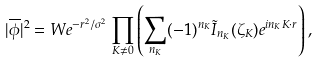Convert formula to latex. <formula><loc_0><loc_0><loc_500><loc_500>| \overline { \phi } | ^ { 2 } = W e ^ { - r ^ { 2 } / \sigma ^ { 2 } } \prod _ { { K } \neq 0 } \left ( \sum _ { n _ { K } } ( - 1 ) ^ { n _ { K } } \tilde { I } _ { n _ { K } } ( \zeta _ { K } ) e ^ { i n _ { K } { K } \cdot { r } } \right ) ,</formula> 